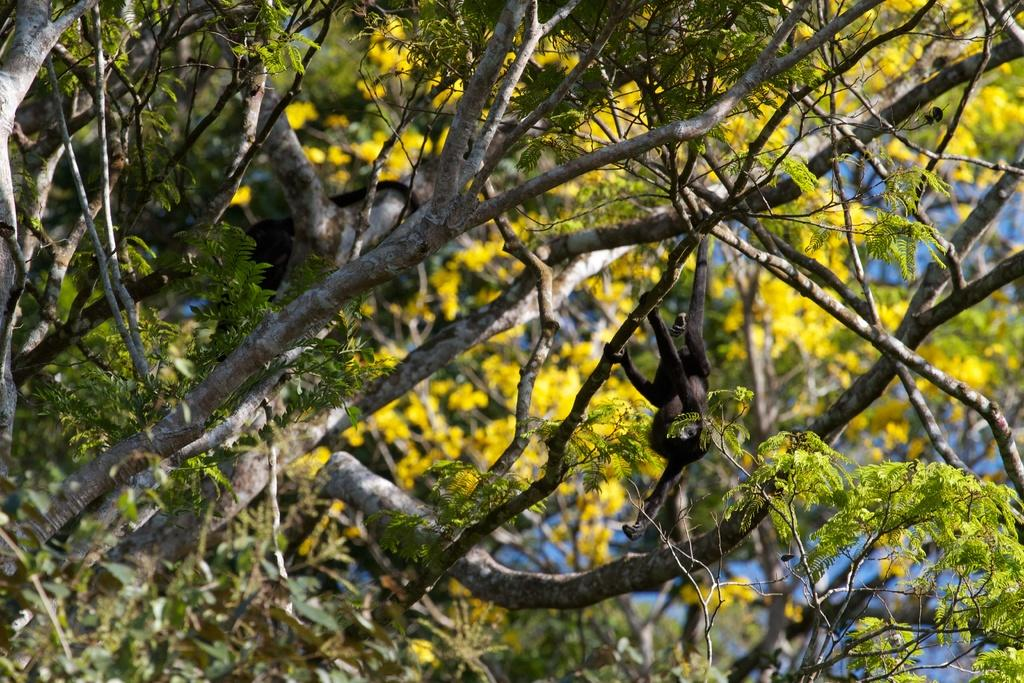What type of plant can be seen in the image? There is a tree in the image. What type of pan is hanging from the tree in the image? There is no pan present in the image; it only features a tree. 